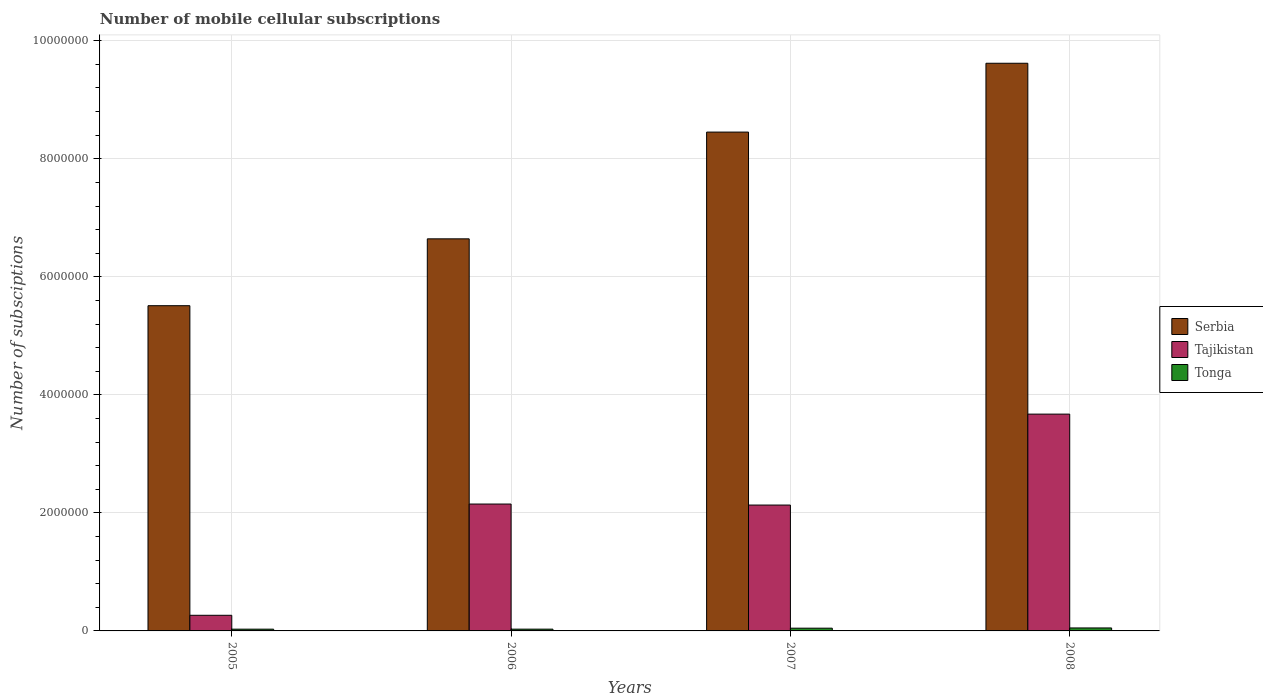Are the number of bars per tick equal to the number of legend labels?
Your answer should be very brief. Yes. Are the number of bars on each tick of the X-axis equal?
Ensure brevity in your answer.  Yes. What is the number of mobile cellular subscriptions in Serbia in 2005?
Make the answer very short. 5.51e+06. Across all years, what is the maximum number of mobile cellular subscriptions in Tonga?
Offer a very short reply. 5.05e+04. Across all years, what is the minimum number of mobile cellular subscriptions in Tajikistan?
Your answer should be very brief. 2.65e+05. In which year was the number of mobile cellular subscriptions in Tajikistan maximum?
Provide a short and direct response. 2008. In which year was the number of mobile cellular subscriptions in Tonga minimum?
Offer a terse response. 2005. What is the total number of mobile cellular subscriptions in Serbia in the graph?
Your response must be concise. 3.02e+07. What is the difference between the number of mobile cellular subscriptions in Tajikistan in 2006 and that in 2008?
Give a very brief answer. -1.52e+06. What is the difference between the number of mobile cellular subscriptions in Tonga in 2007 and the number of mobile cellular subscriptions in Tajikistan in 2005?
Give a very brief answer. -2.18e+05. What is the average number of mobile cellular subscriptions in Tajikistan per year?
Keep it short and to the point. 2.06e+06. In the year 2008, what is the difference between the number of mobile cellular subscriptions in Tonga and number of mobile cellular subscriptions in Tajikistan?
Offer a terse response. -3.62e+06. What is the ratio of the number of mobile cellular subscriptions in Tonga in 2006 to that in 2008?
Give a very brief answer. 0.6. Is the number of mobile cellular subscriptions in Tonga in 2007 less than that in 2008?
Make the answer very short. Yes. What is the difference between the highest and the second highest number of mobile cellular subscriptions in Serbia?
Give a very brief answer. 1.17e+06. What is the difference between the highest and the lowest number of mobile cellular subscriptions in Tajikistan?
Give a very brief answer. 3.41e+06. What does the 2nd bar from the left in 2007 represents?
Give a very brief answer. Tajikistan. What does the 2nd bar from the right in 2007 represents?
Make the answer very short. Tajikistan. How many bars are there?
Make the answer very short. 12. Are all the bars in the graph horizontal?
Provide a short and direct response. No. How many years are there in the graph?
Offer a terse response. 4. What is the difference between two consecutive major ticks on the Y-axis?
Give a very brief answer. 2.00e+06. Are the values on the major ticks of Y-axis written in scientific E-notation?
Your answer should be very brief. No. How many legend labels are there?
Offer a terse response. 3. What is the title of the graph?
Your answer should be very brief. Number of mobile cellular subscriptions. Does "United States" appear as one of the legend labels in the graph?
Offer a very short reply. No. What is the label or title of the Y-axis?
Give a very brief answer. Number of subsciptions. What is the Number of subsciptions in Serbia in 2005?
Make the answer very short. 5.51e+06. What is the Number of subsciptions in Tajikistan in 2005?
Offer a terse response. 2.65e+05. What is the Number of subsciptions in Tonga in 2005?
Provide a succinct answer. 2.99e+04. What is the Number of subsciptions of Serbia in 2006?
Your response must be concise. 6.64e+06. What is the Number of subsciptions in Tajikistan in 2006?
Provide a short and direct response. 2.15e+06. What is the Number of subsciptions in Tonga in 2006?
Your answer should be compact. 3.01e+04. What is the Number of subsciptions in Serbia in 2007?
Make the answer very short. 8.45e+06. What is the Number of subsciptions in Tajikistan in 2007?
Your answer should be compact. 2.13e+06. What is the Number of subsciptions in Tonga in 2007?
Your answer should be very brief. 4.65e+04. What is the Number of subsciptions in Serbia in 2008?
Offer a very short reply. 9.62e+06. What is the Number of subsciptions in Tajikistan in 2008?
Your answer should be compact. 3.67e+06. What is the Number of subsciptions in Tonga in 2008?
Offer a terse response. 5.05e+04. Across all years, what is the maximum Number of subsciptions in Serbia?
Offer a very short reply. 9.62e+06. Across all years, what is the maximum Number of subsciptions of Tajikistan?
Ensure brevity in your answer.  3.67e+06. Across all years, what is the maximum Number of subsciptions in Tonga?
Offer a terse response. 5.05e+04. Across all years, what is the minimum Number of subsciptions in Serbia?
Your answer should be very brief. 5.51e+06. Across all years, what is the minimum Number of subsciptions in Tajikistan?
Offer a very short reply. 2.65e+05. Across all years, what is the minimum Number of subsciptions in Tonga?
Provide a short and direct response. 2.99e+04. What is the total Number of subsciptions in Serbia in the graph?
Offer a terse response. 3.02e+07. What is the total Number of subsciptions of Tajikistan in the graph?
Your answer should be compact. 8.22e+06. What is the total Number of subsciptions in Tonga in the graph?
Offer a very short reply. 1.57e+05. What is the difference between the Number of subsciptions of Serbia in 2005 and that in 2006?
Keep it short and to the point. -1.13e+06. What is the difference between the Number of subsciptions of Tajikistan in 2005 and that in 2006?
Offer a very short reply. -1.88e+06. What is the difference between the Number of subsciptions in Tonga in 2005 and that in 2006?
Keep it short and to the point. -179. What is the difference between the Number of subsciptions of Serbia in 2005 and that in 2007?
Keep it short and to the point. -2.94e+06. What is the difference between the Number of subsciptions of Tajikistan in 2005 and that in 2007?
Make the answer very short. -1.87e+06. What is the difference between the Number of subsciptions in Tonga in 2005 and that in 2007?
Provide a short and direct response. -1.67e+04. What is the difference between the Number of subsciptions in Serbia in 2005 and that in 2008?
Give a very brief answer. -4.11e+06. What is the difference between the Number of subsciptions of Tajikistan in 2005 and that in 2008?
Your answer should be very brief. -3.41e+06. What is the difference between the Number of subsciptions in Tonga in 2005 and that in 2008?
Provide a short and direct response. -2.06e+04. What is the difference between the Number of subsciptions in Serbia in 2006 and that in 2007?
Ensure brevity in your answer.  -1.81e+06. What is the difference between the Number of subsciptions of Tajikistan in 2006 and that in 2007?
Make the answer very short. 1.72e+04. What is the difference between the Number of subsciptions of Tonga in 2006 and that in 2007?
Your answer should be very brief. -1.65e+04. What is the difference between the Number of subsciptions of Serbia in 2006 and that in 2008?
Your answer should be compact. -2.98e+06. What is the difference between the Number of subsciptions in Tajikistan in 2006 and that in 2008?
Ensure brevity in your answer.  -1.52e+06. What is the difference between the Number of subsciptions in Tonga in 2006 and that in 2008?
Your answer should be very brief. -2.04e+04. What is the difference between the Number of subsciptions in Serbia in 2007 and that in 2008?
Your response must be concise. -1.17e+06. What is the difference between the Number of subsciptions in Tajikistan in 2007 and that in 2008?
Offer a terse response. -1.54e+06. What is the difference between the Number of subsciptions in Tonga in 2007 and that in 2008?
Offer a terse response. -3947. What is the difference between the Number of subsciptions of Serbia in 2005 and the Number of subsciptions of Tajikistan in 2006?
Make the answer very short. 3.36e+06. What is the difference between the Number of subsciptions in Serbia in 2005 and the Number of subsciptions in Tonga in 2006?
Keep it short and to the point. 5.48e+06. What is the difference between the Number of subsciptions in Tajikistan in 2005 and the Number of subsciptions in Tonga in 2006?
Make the answer very short. 2.35e+05. What is the difference between the Number of subsciptions in Serbia in 2005 and the Number of subsciptions in Tajikistan in 2007?
Your response must be concise. 3.38e+06. What is the difference between the Number of subsciptions of Serbia in 2005 and the Number of subsciptions of Tonga in 2007?
Provide a succinct answer. 5.46e+06. What is the difference between the Number of subsciptions in Tajikistan in 2005 and the Number of subsciptions in Tonga in 2007?
Ensure brevity in your answer.  2.18e+05. What is the difference between the Number of subsciptions of Serbia in 2005 and the Number of subsciptions of Tajikistan in 2008?
Ensure brevity in your answer.  1.84e+06. What is the difference between the Number of subsciptions in Serbia in 2005 and the Number of subsciptions in Tonga in 2008?
Offer a very short reply. 5.46e+06. What is the difference between the Number of subsciptions of Tajikistan in 2005 and the Number of subsciptions of Tonga in 2008?
Offer a very short reply. 2.15e+05. What is the difference between the Number of subsciptions in Serbia in 2006 and the Number of subsciptions in Tajikistan in 2007?
Ensure brevity in your answer.  4.51e+06. What is the difference between the Number of subsciptions in Serbia in 2006 and the Number of subsciptions in Tonga in 2007?
Offer a very short reply. 6.60e+06. What is the difference between the Number of subsciptions in Tajikistan in 2006 and the Number of subsciptions in Tonga in 2007?
Provide a short and direct response. 2.10e+06. What is the difference between the Number of subsciptions of Serbia in 2006 and the Number of subsciptions of Tajikistan in 2008?
Your response must be concise. 2.97e+06. What is the difference between the Number of subsciptions in Serbia in 2006 and the Number of subsciptions in Tonga in 2008?
Offer a very short reply. 6.59e+06. What is the difference between the Number of subsciptions in Tajikistan in 2006 and the Number of subsciptions in Tonga in 2008?
Provide a short and direct response. 2.10e+06. What is the difference between the Number of subsciptions in Serbia in 2007 and the Number of subsciptions in Tajikistan in 2008?
Keep it short and to the point. 4.78e+06. What is the difference between the Number of subsciptions of Serbia in 2007 and the Number of subsciptions of Tonga in 2008?
Make the answer very short. 8.40e+06. What is the difference between the Number of subsciptions in Tajikistan in 2007 and the Number of subsciptions in Tonga in 2008?
Your answer should be very brief. 2.08e+06. What is the average Number of subsciptions of Serbia per year?
Provide a succinct answer. 7.56e+06. What is the average Number of subsciptions in Tajikistan per year?
Provide a succinct answer. 2.06e+06. What is the average Number of subsciptions in Tonga per year?
Your answer should be compact. 3.92e+04. In the year 2005, what is the difference between the Number of subsciptions in Serbia and Number of subsciptions in Tajikistan?
Give a very brief answer. 5.25e+06. In the year 2005, what is the difference between the Number of subsciptions of Serbia and Number of subsciptions of Tonga?
Give a very brief answer. 5.48e+06. In the year 2005, what is the difference between the Number of subsciptions in Tajikistan and Number of subsciptions in Tonga?
Your response must be concise. 2.35e+05. In the year 2006, what is the difference between the Number of subsciptions in Serbia and Number of subsciptions in Tajikistan?
Your answer should be compact. 4.49e+06. In the year 2006, what is the difference between the Number of subsciptions in Serbia and Number of subsciptions in Tonga?
Your answer should be very brief. 6.61e+06. In the year 2006, what is the difference between the Number of subsciptions in Tajikistan and Number of subsciptions in Tonga?
Your answer should be very brief. 2.12e+06. In the year 2007, what is the difference between the Number of subsciptions of Serbia and Number of subsciptions of Tajikistan?
Your response must be concise. 6.32e+06. In the year 2007, what is the difference between the Number of subsciptions in Serbia and Number of subsciptions in Tonga?
Give a very brief answer. 8.41e+06. In the year 2007, what is the difference between the Number of subsciptions of Tajikistan and Number of subsciptions of Tonga?
Offer a very short reply. 2.09e+06. In the year 2008, what is the difference between the Number of subsciptions in Serbia and Number of subsciptions in Tajikistan?
Ensure brevity in your answer.  5.95e+06. In the year 2008, what is the difference between the Number of subsciptions in Serbia and Number of subsciptions in Tonga?
Provide a short and direct response. 9.57e+06. In the year 2008, what is the difference between the Number of subsciptions in Tajikistan and Number of subsciptions in Tonga?
Offer a very short reply. 3.62e+06. What is the ratio of the Number of subsciptions of Serbia in 2005 to that in 2006?
Provide a short and direct response. 0.83. What is the ratio of the Number of subsciptions in Tajikistan in 2005 to that in 2006?
Offer a terse response. 0.12. What is the ratio of the Number of subsciptions in Serbia in 2005 to that in 2007?
Offer a very short reply. 0.65. What is the ratio of the Number of subsciptions in Tajikistan in 2005 to that in 2007?
Your answer should be very brief. 0.12. What is the ratio of the Number of subsciptions in Tonga in 2005 to that in 2007?
Make the answer very short. 0.64. What is the ratio of the Number of subsciptions of Serbia in 2005 to that in 2008?
Your response must be concise. 0.57. What is the ratio of the Number of subsciptions in Tajikistan in 2005 to that in 2008?
Provide a short and direct response. 0.07. What is the ratio of the Number of subsciptions in Tonga in 2005 to that in 2008?
Offer a very short reply. 0.59. What is the ratio of the Number of subsciptions in Serbia in 2006 to that in 2007?
Your response must be concise. 0.79. What is the ratio of the Number of subsciptions in Tajikistan in 2006 to that in 2007?
Give a very brief answer. 1.01. What is the ratio of the Number of subsciptions of Tonga in 2006 to that in 2007?
Provide a short and direct response. 0.65. What is the ratio of the Number of subsciptions in Serbia in 2006 to that in 2008?
Your response must be concise. 0.69. What is the ratio of the Number of subsciptions in Tajikistan in 2006 to that in 2008?
Make the answer very short. 0.59. What is the ratio of the Number of subsciptions of Tonga in 2006 to that in 2008?
Ensure brevity in your answer.  0.6. What is the ratio of the Number of subsciptions in Serbia in 2007 to that in 2008?
Make the answer very short. 0.88. What is the ratio of the Number of subsciptions in Tajikistan in 2007 to that in 2008?
Offer a terse response. 0.58. What is the ratio of the Number of subsciptions of Tonga in 2007 to that in 2008?
Give a very brief answer. 0.92. What is the difference between the highest and the second highest Number of subsciptions in Serbia?
Provide a short and direct response. 1.17e+06. What is the difference between the highest and the second highest Number of subsciptions of Tajikistan?
Keep it short and to the point. 1.52e+06. What is the difference between the highest and the second highest Number of subsciptions of Tonga?
Give a very brief answer. 3947. What is the difference between the highest and the lowest Number of subsciptions in Serbia?
Keep it short and to the point. 4.11e+06. What is the difference between the highest and the lowest Number of subsciptions in Tajikistan?
Your answer should be compact. 3.41e+06. What is the difference between the highest and the lowest Number of subsciptions in Tonga?
Make the answer very short. 2.06e+04. 